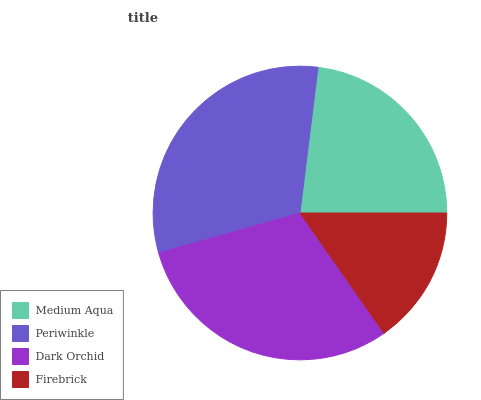Is Firebrick the minimum?
Answer yes or no. Yes. Is Periwinkle the maximum?
Answer yes or no. Yes. Is Dark Orchid the minimum?
Answer yes or no. No. Is Dark Orchid the maximum?
Answer yes or no. No. Is Periwinkle greater than Dark Orchid?
Answer yes or no. Yes. Is Dark Orchid less than Periwinkle?
Answer yes or no. Yes. Is Dark Orchid greater than Periwinkle?
Answer yes or no. No. Is Periwinkle less than Dark Orchid?
Answer yes or no. No. Is Dark Orchid the high median?
Answer yes or no. Yes. Is Medium Aqua the low median?
Answer yes or no. Yes. Is Firebrick the high median?
Answer yes or no. No. Is Periwinkle the low median?
Answer yes or no. No. 